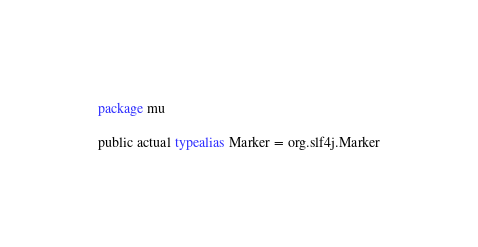<code> <loc_0><loc_0><loc_500><loc_500><_Kotlin_>package mu

public actual typealias Marker = org.slf4j.Marker
</code> 